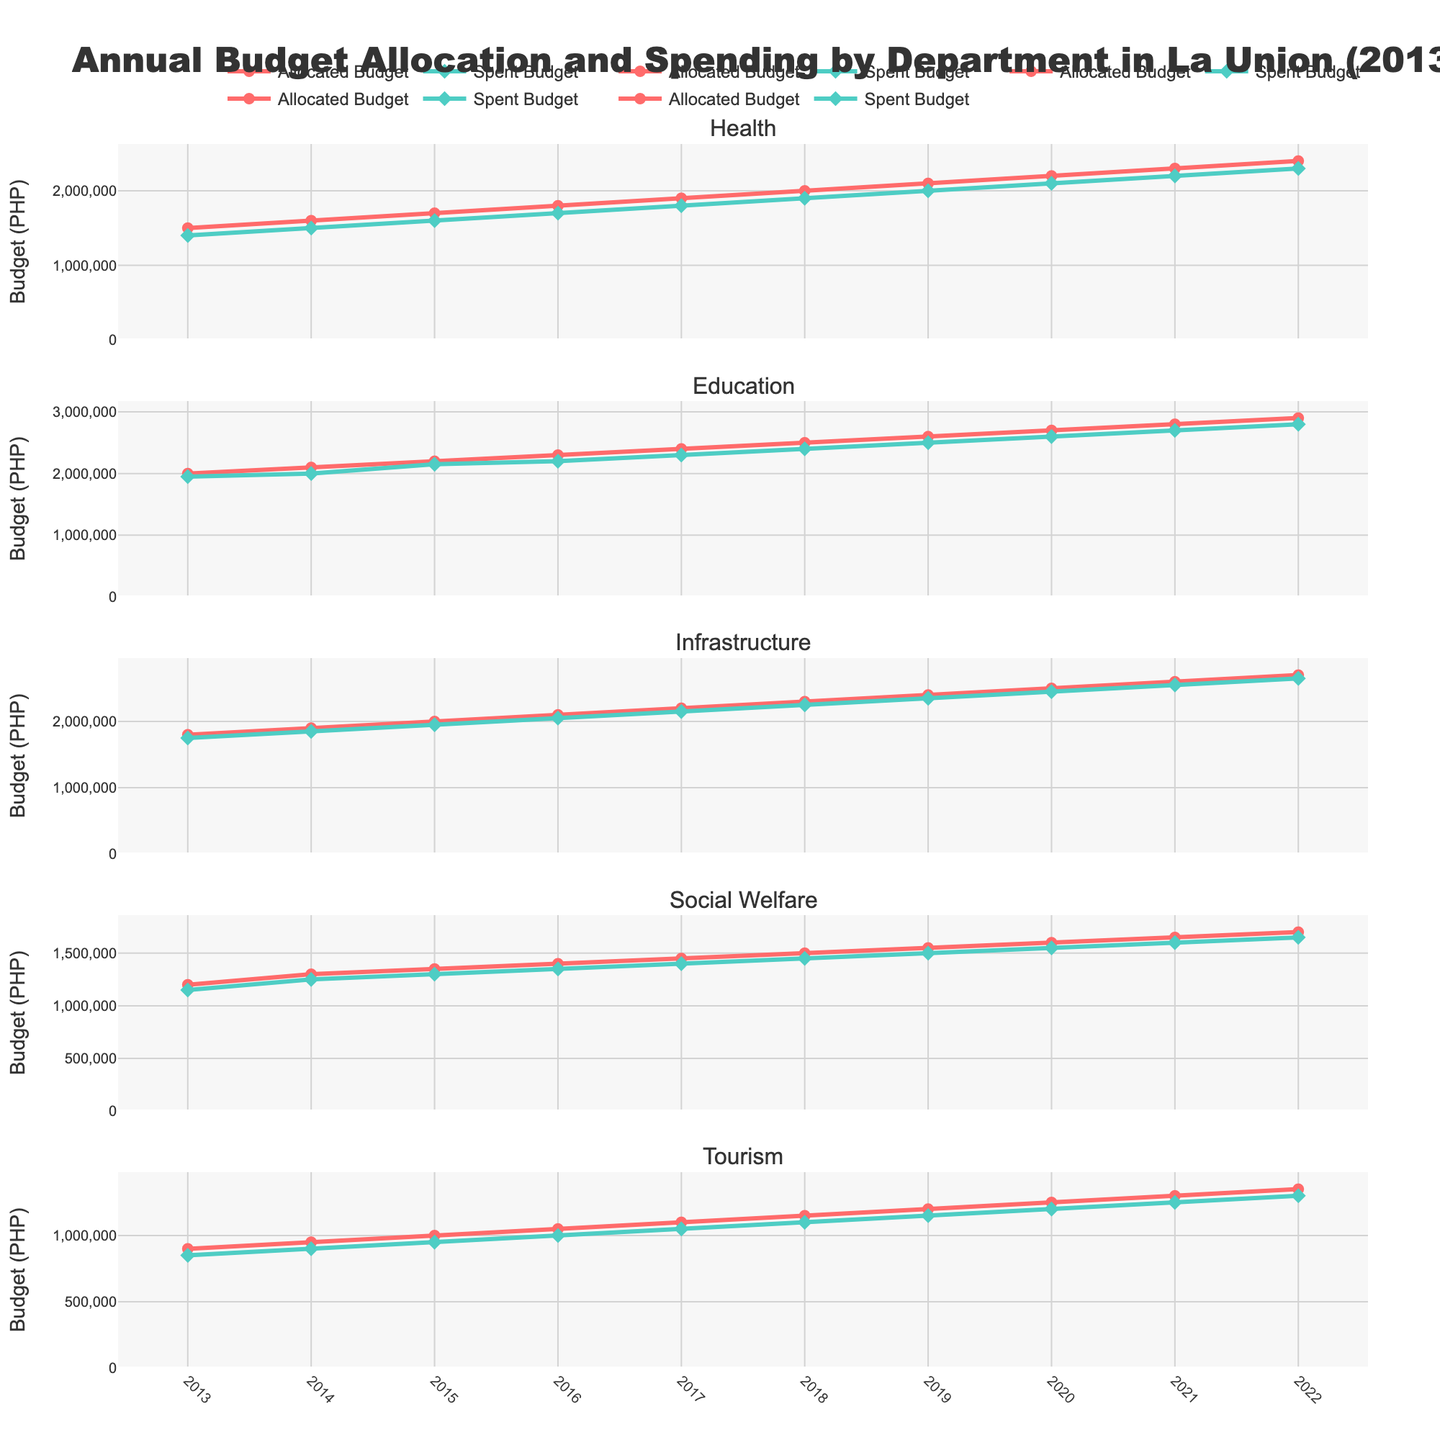What is the title of the figure? The title of the figure is typically displayed at the top and provides an overview of what the plot is about. In this case, the title reads "Annual Budget Allocation and Spending by Department in La Union (2013-2022)."
Answer: "Annual Budget Allocation and Spending by Department in La Union (2013-2022)" What is the range of years displayed on the x-axis? The x-axis represents the timeline for the data. It starts from 2013 and ends in 2022, as indicated by the ticks on the x-axis.
Answer: 2013-2022 Which department has the highest allocated budget in 2022? To determine this, look at the allocated budget values for all departments in the year 2022. The department with the highest value is Education with an allocated budget of 2,900,000 PHP.
Answer: Education How does the allocated budget for the Health department change over time? Examine the allocated budget data points for the Health department across the years from 2013 to 2022. The allocated budget steadily increases each year. For example, it starts at 1,500,000 PHP in 2013 and rises to 2,400,000 PHP in 2022.
Answer: Increases steadily What is the difference between the allocated and spent budget for the Tourism department in 2019? Locate the values for the allocated and spent budgets for the Tourism department in 2019. The allocated budget is 1,200,000 PHP, and the spent budget is 1,150,000 PHP. Subtract the spent budget from the allocated budget: 1,200,000 - 1,150,000 = 50,000 PHP.
Answer: 50,000 PHP Which department has shown the smallest increase in allocated budget from 2013 to 2022? Calculate the increase for each department by subtracting the 2013 value from the 2022 value. Health: 900,000 PHP, Education: 900,000 PHP, Infrastructure: 900,000 PHP, Social Welfare: 500,000 PHP, Tourism: 450,000 PHP. The smallest increase is in the Tourism department.
Answer: Tourism Did any department have a year where the spent budget exceeded the allocated budget? If so, name the department and year. Examine the year-to-year data for each department. There is no instance where the spent budget exceeds the allocated budget for any department from 2013 to 2022.
Answer: No What pattern can be observed in the spending habits of the Infrastructure department over the years? Analyze the trend of the spent budget for the Infrastructure department from 2013 to 2022. The spent budget consistently follows the allocated budget closely without significant deviations, suggesting disciplined spending habits.
Answer: Close to allocated budget 